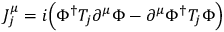<formula> <loc_0><loc_0><loc_500><loc_500>J _ { j } ^ { \mu } = i \left ( \Phi ^ { \dagger } T _ { j } \partial ^ { \mu } \Phi - \partial ^ { \mu } \Phi ^ { \dagger } T _ { j } \Phi \right )</formula> 